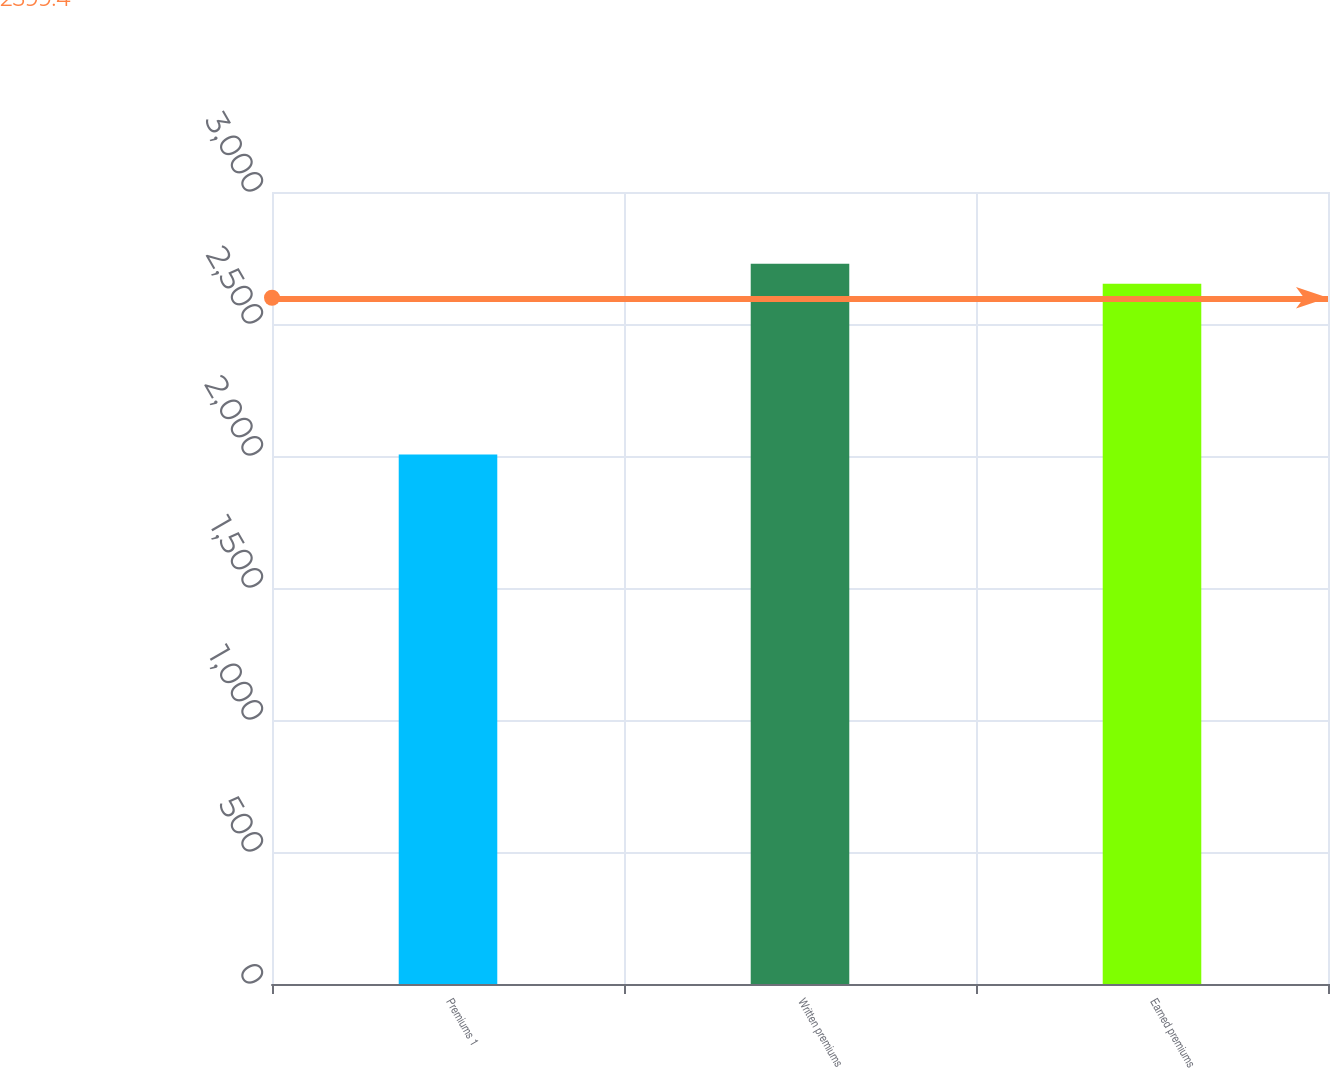Convert chart to OTSL. <chart><loc_0><loc_0><loc_500><loc_500><bar_chart><fcel>Premiums 1<fcel>Written premiums<fcel>Earned premiums<nl><fcel>2006<fcel>2728<fcel>2652<nl></chart> 